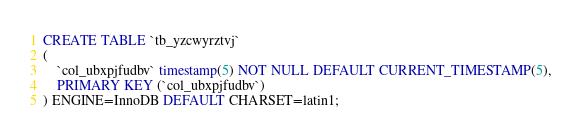Convert code to text. <code><loc_0><loc_0><loc_500><loc_500><_SQL_>CREATE TABLE `tb_yzcwyrztvj`
(
    `col_ubxpjfudbv` timestamp(5) NOT NULL DEFAULT CURRENT_TIMESTAMP(5),
    PRIMARY KEY (`col_ubxpjfudbv`)
) ENGINE=InnoDB DEFAULT CHARSET=latin1;
</code> 